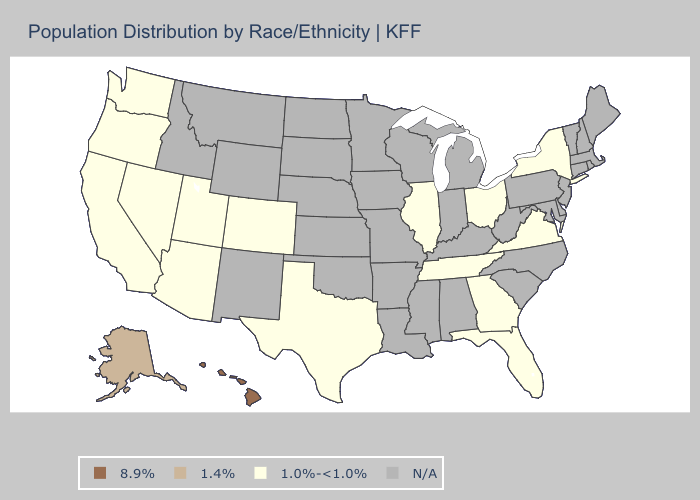Does California have the highest value in the USA?
Be succinct. No. Which states have the lowest value in the USA?
Concise answer only. Arizona, California, Colorado, Florida, Georgia, Illinois, Nevada, New York, Ohio, Oregon, Tennessee, Texas, Utah, Virginia, Washington. What is the highest value in the USA?
Write a very short answer. 8.9%. What is the lowest value in states that border West Virginia?
Give a very brief answer. 1.0%-<1.0%. Does the map have missing data?
Quick response, please. Yes. Does the first symbol in the legend represent the smallest category?
Quick response, please. No. What is the value of Montana?
Concise answer only. N/A. Does Arizona have the highest value in the USA?
Short answer required. No. Does Tennessee have the lowest value in the USA?
Answer briefly. Yes. How many symbols are there in the legend?
Keep it brief. 4. Among the states that border New Mexico , which have the lowest value?
Answer briefly. Arizona, Colorado, Texas, Utah. What is the value of Maryland?
Answer briefly. N/A. What is the value of Arkansas?
Quick response, please. N/A. 